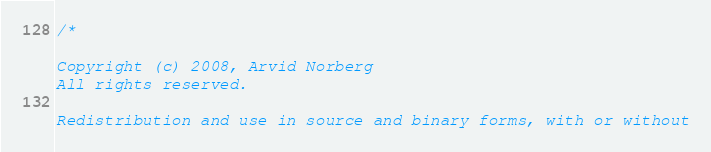<code> <loc_0><loc_0><loc_500><loc_500><_C++_>/*

Copyright (c) 2008, Arvid Norberg
All rights reserved.

Redistribution and use in source and binary forms, with or without</code> 